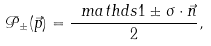<formula> <loc_0><loc_0><loc_500><loc_500>\mathcal { P } _ { \pm } ( \vec { p } ) = \frac { \ m a t h d s { 1 } \pm \sigma \cdot \vec { n } } { 2 } ,</formula> 